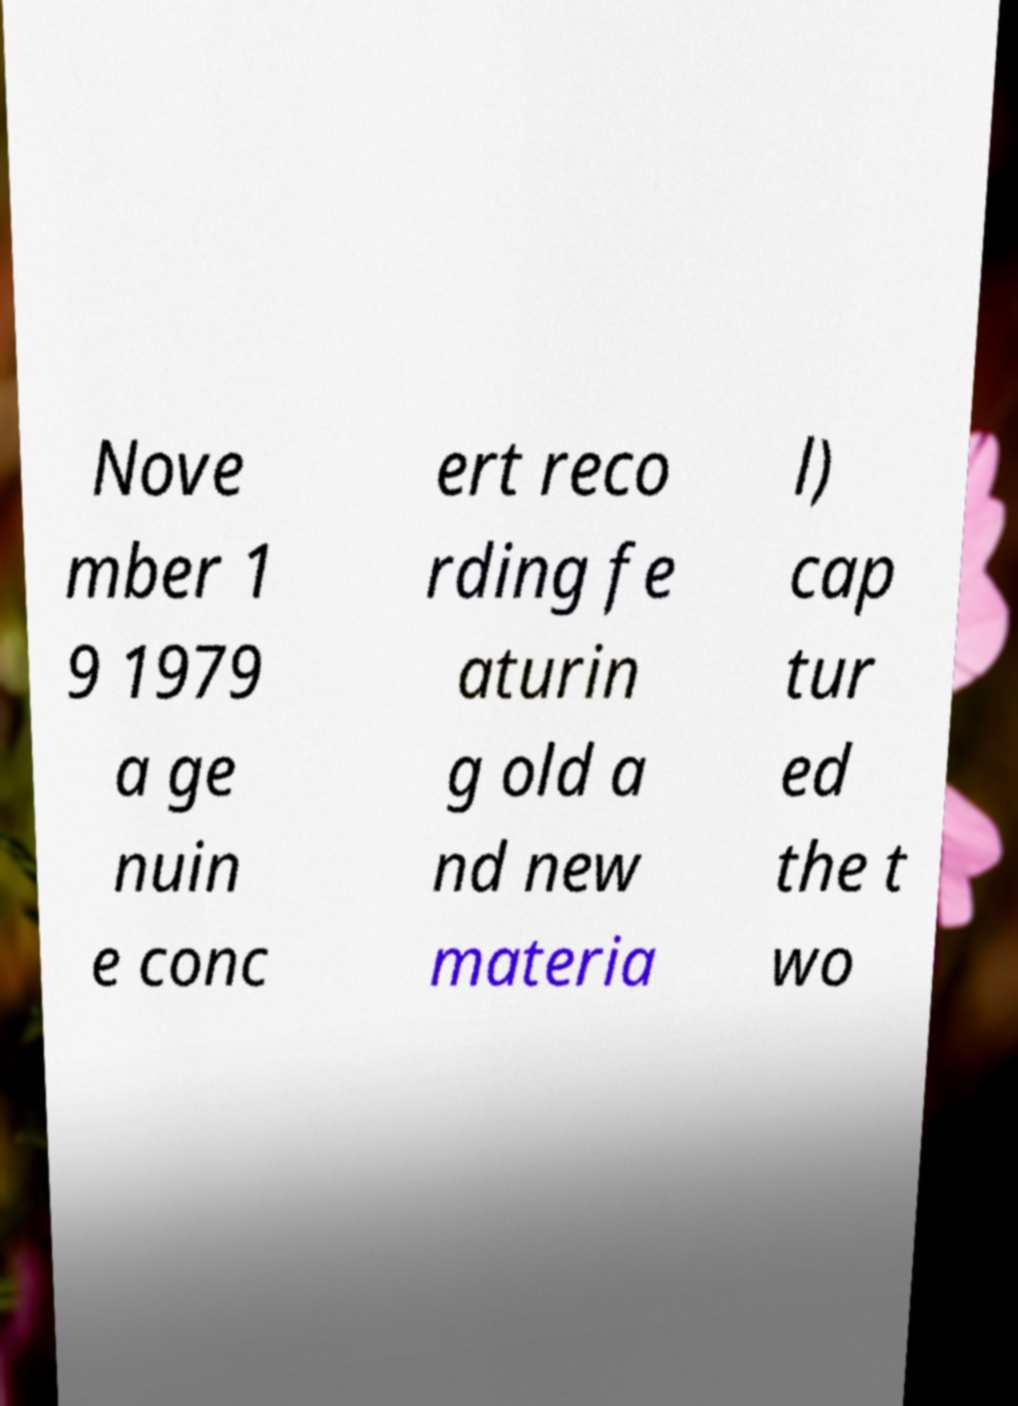Please read and relay the text visible in this image. What does it say? Nove mber 1 9 1979 a ge nuin e conc ert reco rding fe aturin g old a nd new materia l) cap tur ed the t wo 